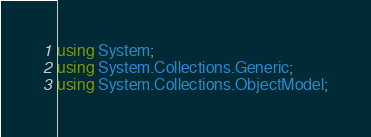<code> <loc_0><loc_0><loc_500><loc_500><_C#_>using System;
using System.Collections.Generic;
using System.Collections.ObjectModel;</code> 